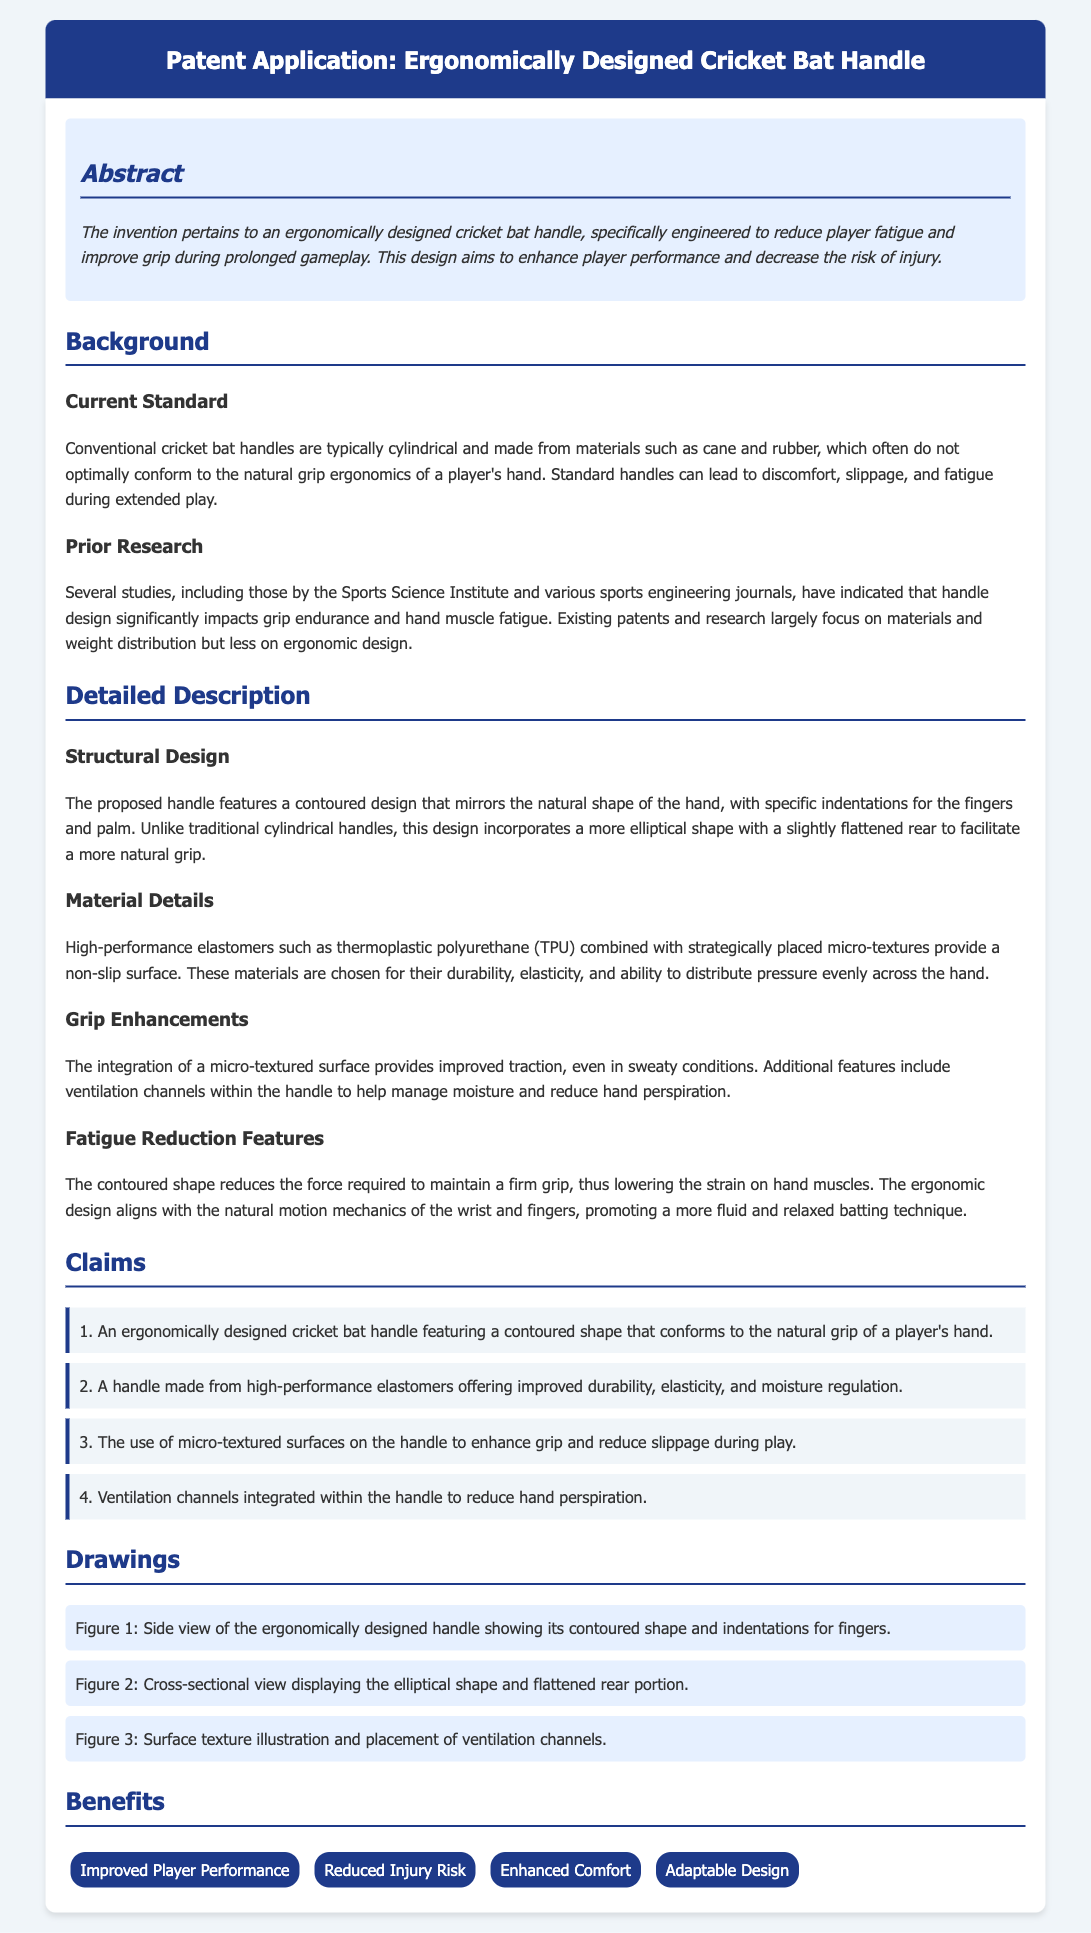What is the primary focus of the invention? The invention pertains to an ergonomically designed cricket bat handle, specifically engineered to reduce player fatigue and improve grip during prolonged gameplay.
Answer: Reducing player fatigue and improving grip What materials are used in the grip design? High-performance elastomers such as thermoplastic polyurethane (TPU) combined with strategically placed micro-textures are used to provide a non-slip surface.
Answer: Thermoplastic polyurethane (TPU) What feature helps manage moisture in the handle? The document mentions integrated ventilation channels within the handle to help manage moisture and reduce hand perspiration.
Answer: Ventilation channels Which claim describes the surface texture? The use of micro-textured surfaces on the handle to enhance grip and reduce slippage during play is noted in claim three.
Answer: Claim 3 What ergonomic shape does the handle design feature? The proposed handle features a contoured design that mirrors the natural shape of the hand, incorporating a more elliptical shape with a slightly flattened rear.
Answer: Contoured design How many benefits are listed for the new handle design? The benefits section lists four specific benefits associated with the ergonomic design of the cricket bat handle.
Answer: Four benefits What is one way the design helps reduce player fatigue? The contoured shape reduces the force required to maintain a firm grip, thereby lowering strain on hand muscles.
Answer: Reduces force required to grip What does the term "micro-textured surface" refer to? It refers to a surface enhancement that provides improved traction, even in sweaty conditions, as described in the grip enhancements section.
Answer: Improved traction How many claims are made in the patent application? The document includes four distinct claims regarding the features of the ergonomically designed cricket bat handle.
Answer: Four claims 